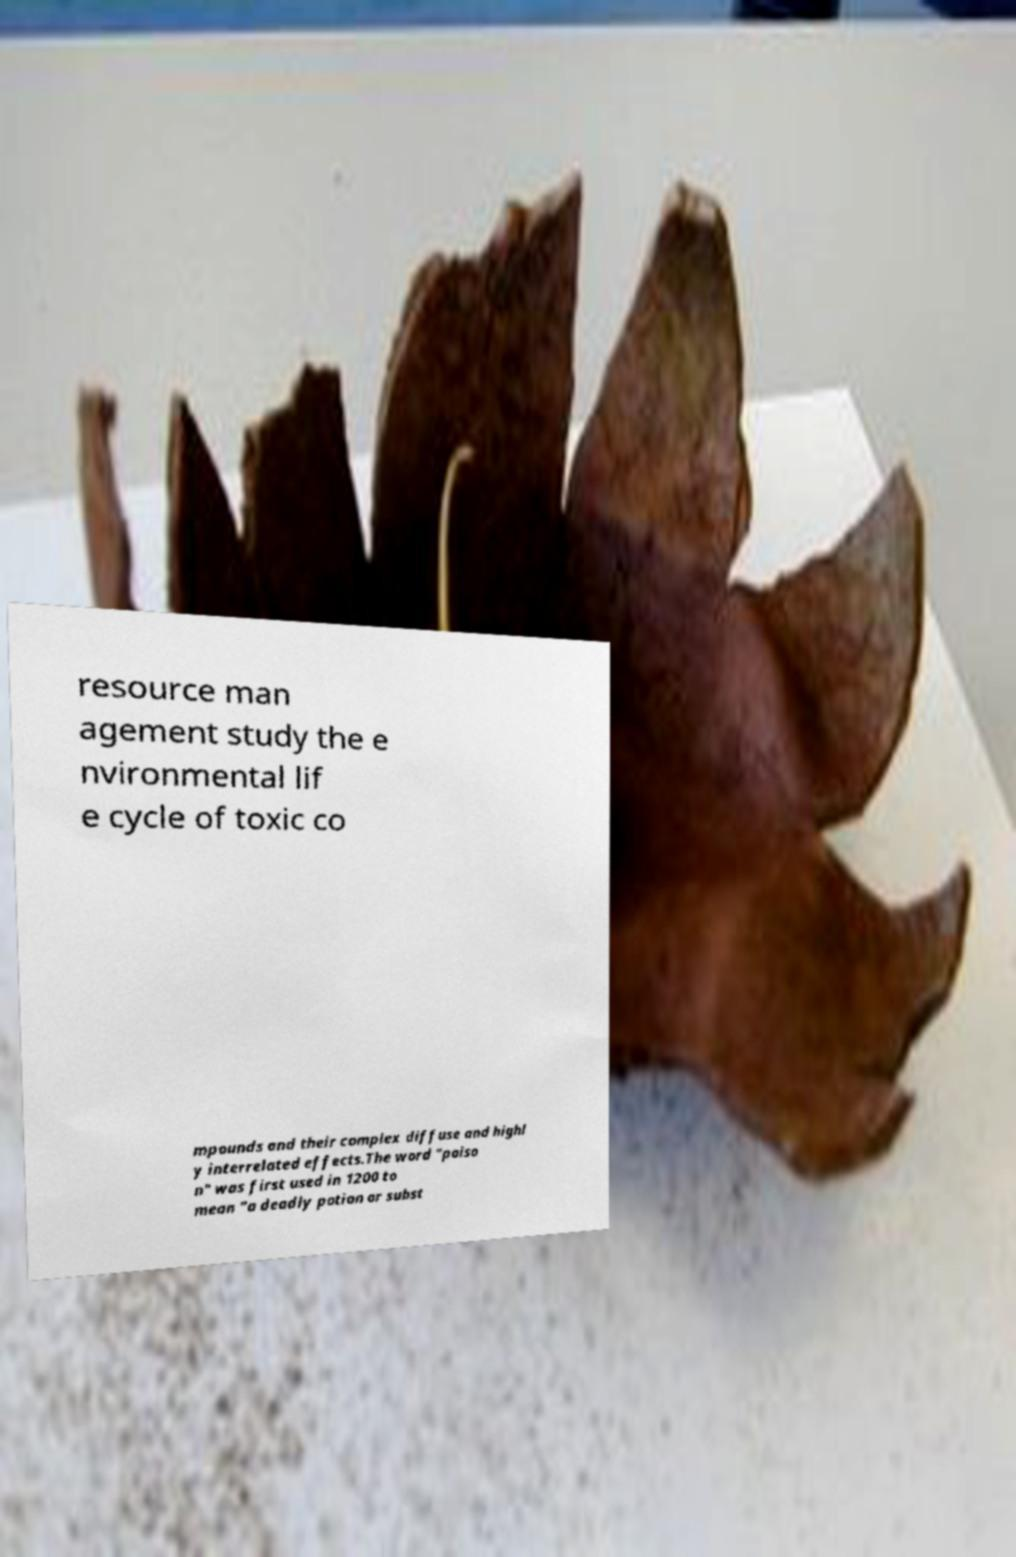For documentation purposes, I need the text within this image transcribed. Could you provide that? resource man agement study the e nvironmental lif e cycle of toxic co mpounds and their complex diffuse and highl y interrelated effects.The word "poiso n" was first used in 1200 to mean "a deadly potion or subst 